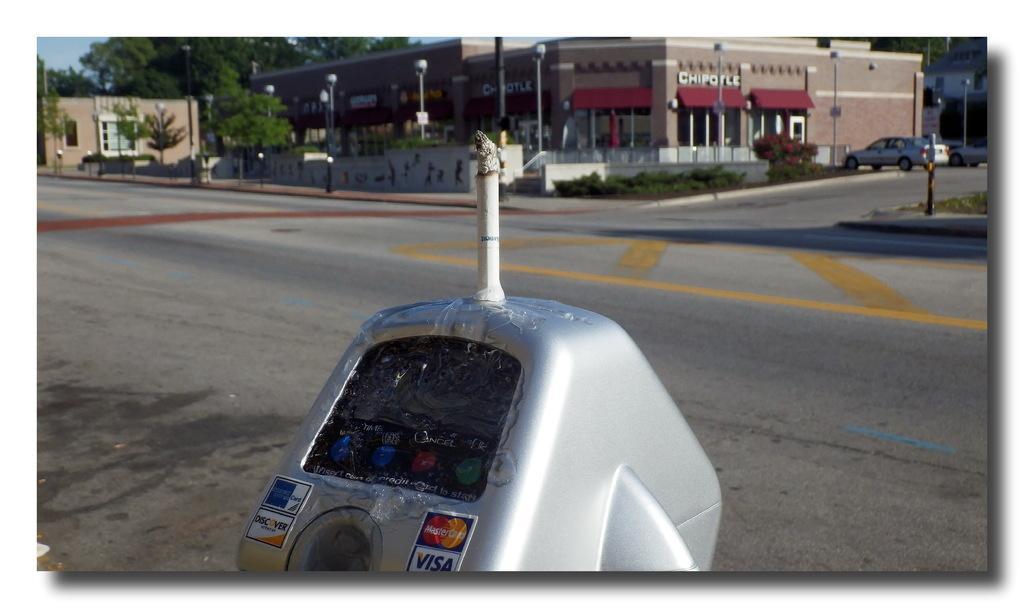Can you describe this image briefly? This looks like a parking meter. This is the road. I can see a building with glass doors and name boards. I think these are the streetlights. I can see two cars, which are parked. These are the small bushes and trees. 